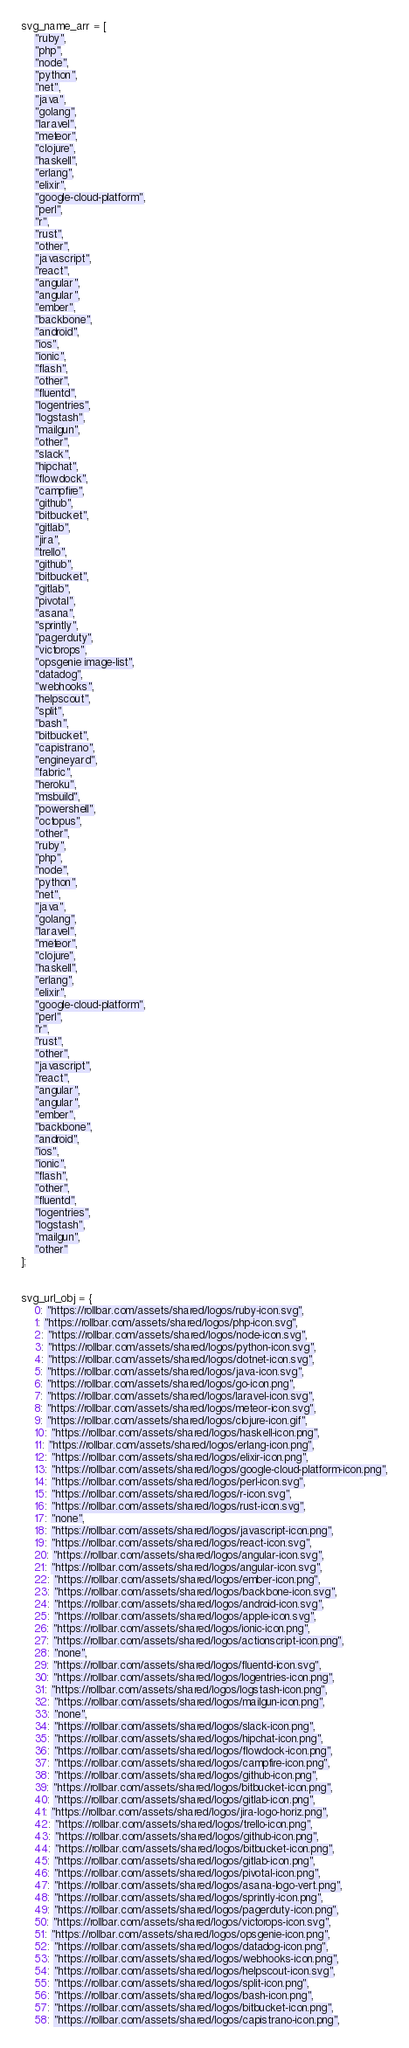Convert code to text. <code><loc_0><loc_0><loc_500><loc_500><_JavaScript_>svg_name_arr = [
    "ruby",
    "php",
    "node",
    "python",
    "net",
    "java",
    "golang",
    "laravel",
    "meteor",
    "clojure",
    "haskell",
    "erlang",
    "elixir",
    "google-cloud-platform",
    "perl",
    "r",
    "rust",
    "other",
    "javascript",
    "react",
    "angular",
    "angular",
    "ember",
    "backbone",
    "android",
    "ios",
    "ionic",
    "flash",
    "other",
    "fluentd",
    "logentries",
    "logstash",
    "mailgun",
    "other",
    "slack",
    "hipchat",
    "flowdock",
    "campfire",
    "github",
    "bitbucket",
    "gitlab",
    "jira",
    "trello",
    "github",
    "bitbucket",
    "gitlab",
    "pivotal",
    "asana",
    "sprintly",
    "pagerduty",
    "victorops",
    "opsgenie image-list",
    "datadog",
    "webhooks",
    "helpscout",
    "split",
    "bash",
    "bitbucket",
    "capistrano",
    "engineyard",
    "fabric",
    "heroku",
    "msbuild",
    "powershell",
    "octopus",
    "other",
    "ruby",
    "php",
    "node",
    "python",
    "net",
    "java",
    "golang",
    "laravel",
    "meteor",
    "clojure",
    "haskell",
    "erlang",
    "elixir",
    "google-cloud-platform",
    "perl",
    "r",
    "rust",
    "other",
    "javascript",
    "react",
    "angular",
    "angular",
    "ember",
    "backbone",
    "android",
    "ios",
    "ionic",
    "flash",
    "other",
    "fluentd",
    "logentries",
    "logstash",
    "mailgun",
    "other"
];


svg_url_obj = {
    0: "https://rollbar.com/assets/shared/logos/ruby-icon.svg",
    1: "https://rollbar.com/assets/shared/logos/php-icon.svg",
    2: "https://rollbar.com/assets/shared/logos/node-icon.svg",
    3: "https://rollbar.com/assets/shared/logos/python-icon.svg",
    4: "https://rollbar.com/assets/shared/logos/dotnet-icon.svg",
    5: "https://rollbar.com/assets/shared/logos/java-icon.svg",
    6: "https://rollbar.com/assets/shared/logos/go-icon.png",
    7: "https://rollbar.com/assets/shared/logos/laravel-icon.svg",
    8: "https://rollbar.com/assets/shared/logos/meteor-icon.svg",
    9: "https://rollbar.com/assets/shared/logos/clojure-icon.gif",
    10: "https://rollbar.com/assets/shared/logos/haskell-icon.png",
    11: "https://rollbar.com/assets/shared/logos/erlang-icon.png",
    12: "https://rollbar.com/assets/shared/logos/elixir-icon.png",
    13: "https://rollbar.com/assets/shared/logos/google-cloud-platform-icon.png",
    14: "https://rollbar.com/assets/shared/logos/perl-icon.svg",
    15: "https://rollbar.com/assets/shared/logos/r-icon.svg",
    16: "https://rollbar.com/assets/shared/logos/rust-icon.svg",
    17: "none",
    18: "https://rollbar.com/assets/shared/logos/javascript-icon.png",
    19: "https://rollbar.com/assets/shared/logos/react-icon.svg",
    20: "https://rollbar.com/assets/shared/logos/angular-icon.svg",
    21: "https://rollbar.com/assets/shared/logos/angular-icon.svg",
    22: "https://rollbar.com/assets/shared/logos/ember-icon.png",
    23: "https://rollbar.com/assets/shared/logos/backbone-icon.svg",
    24: "https://rollbar.com/assets/shared/logos/android-icon.svg",
    25: "https://rollbar.com/assets/shared/logos/apple-icon.svg",
    26: "https://rollbar.com/assets/shared/logos/ionic-icon.png",
    27: "https://rollbar.com/assets/shared/logos/actionscript-icon.png",
    28: "none",
    29: "https://rollbar.com/assets/shared/logos/fluentd-icon.svg",
    30: "https://rollbar.com/assets/shared/logos/logentries-icon.png",
    31: "https://rollbar.com/assets/shared/logos/logstash-icon.png",
    32: "https://rollbar.com/assets/shared/logos/mailgun-icon.png",
    33: "none",
    34: "https://rollbar.com/assets/shared/logos/slack-icon.png",
    35: "https://rollbar.com/assets/shared/logos/hipchat-icon.png",
    36: "https://rollbar.com/assets/shared/logos/flowdock-icon.png",
    37: "https://rollbar.com/assets/shared/logos/campfire-icon.png",
    38: "https://rollbar.com/assets/shared/logos/github-icon.png",
    39: "https://rollbar.com/assets/shared/logos/bitbucket-icon.png",
    40: "https://rollbar.com/assets/shared/logos/gitlab-icon.png",
    41: "https://rollbar.com/assets/shared/logos/jira-logo-horiz.png",
    42: "https://rollbar.com/assets/shared/logos/trello-icon.png",
    43: "https://rollbar.com/assets/shared/logos/github-icon.png",
    44: "https://rollbar.com/assets/shared/logos/bitbucket-icon.png",
    45: "https://rollbar.com/assets/shared/logos/gitlab-icon.png",
    46: "https://rollbar.com/assets/shared/logos/pivotal-icon.png",
    47: "https://rollbar.com/assets/shared/logos/asana-logo-vert.png",
    48: "https://rollbar.com/assets/shared/logos/sprintly-icon.png",
    49: "https://rollbar.com/assets/shared/logos/pagerduty-icon.png",
    50: "https://rollbar.com/assets/shared/logos/victorops-icon.svg",
    51: "https://rollbar.com/assets/shared/logos/opsgenie-icon.png",
    52: "https://rollbar.com/assets/shared/logos/datadog-icon.png",
    53: "https://rollbar.com/assets/shared/logos/webhooks-icon.png",
    54: "https://rollbar.com/assets/shared/logos/helpscout-icon.svg",
    55: "https://rollbar.com/assets/shared/logos/split-icon.png",
    56: "https://rollbar.com/assets/shared/logos/bash-icon.png",
    57: "https://rollbar.com/assets/shared/logos/bitbucket-icon.png",
    58: "https://rollbar.com/assets/shared/logos/capistrano-icon.png",</code> 